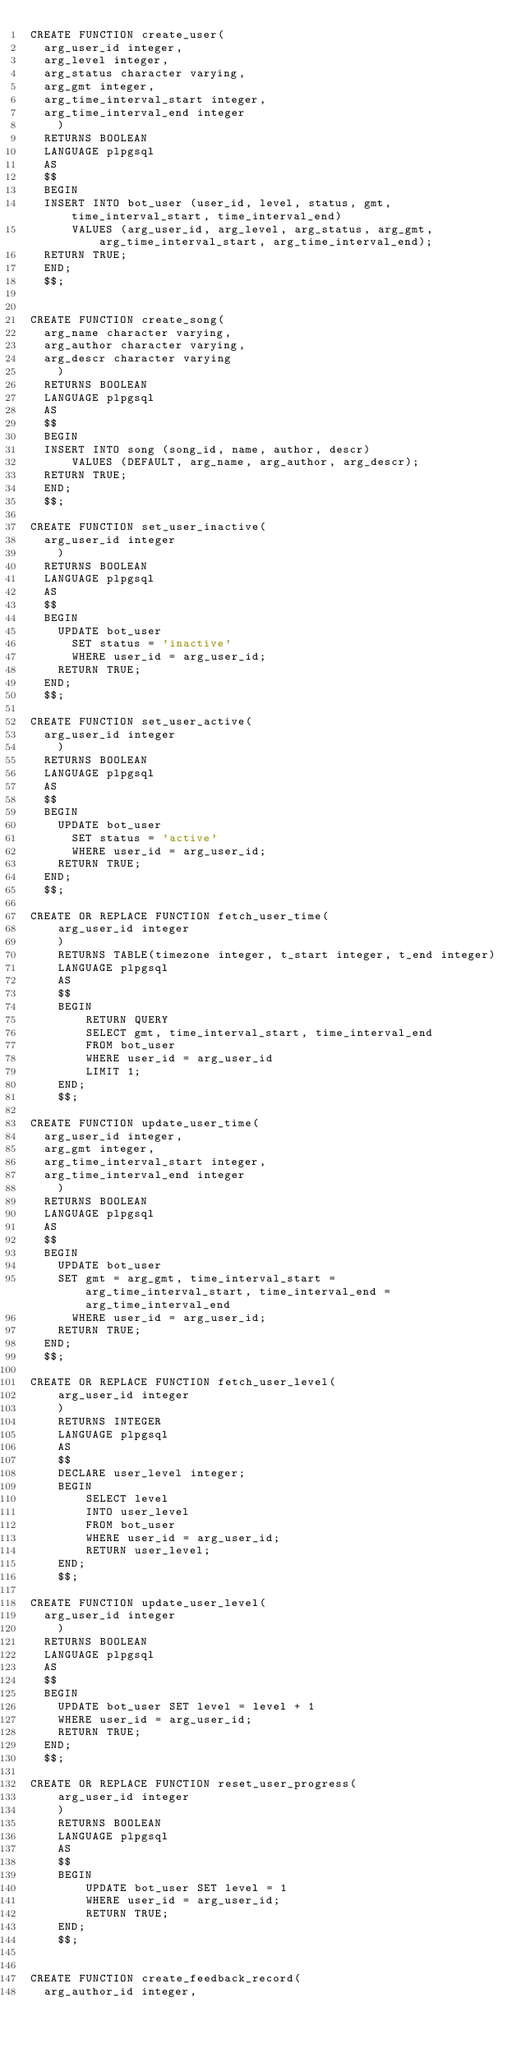<code> <loc_0><loc_0><loc_500><loc_500><_SQL_>CREATE FUNCTION create_user(
	arg_user_id integer,
	arg_level integer,
	arg_status character varying,
	arg_gmt integer,
	arg_time_interval_start integer,
	arg_time_interval_end integer
    )
	RETURNS BOOLEAN
	LANGUAGE plpgsql
	AS
	$$
	BEGIN
	INSERT INTO bot_user (user_id, level, status, gmt, time_interval_start, time_interval_end)
    	VALUES (arg_user_id, arg_level, arg_status, arg_gmt, arg_time_interval_start, arg_time_interval_end);
	RETURN TRUE;
	END;
	$$;


CREATE FUNCTION create_song(
	arg_name character varying,
	arg_author character varying,
	arg_descr character varying
    )
	RETURNS BOOLEAN
	LANGUAGE plpgsql
	AS
	$$
	BEGIN
	INSERT INTO song (song_id, name, author, descr)
    	VALUES (DEFAULT, arg_name, arg_author, arg_descr);
	RETURN TRUE;
	END;
	$$;
	
CREATE FUNCTION set_user_inactive(
	arg_user_id integer
    )
	RETURNS BOOLEAN
	LANGUAGE plpgsql
	AS
	$$
	BEGIN
		UPDATE bot_user
    	SET status = 'inactive'
    	WHERE user_id = arg_user_id;
		RETURN TRUE;
	END;
	$$;

CREATE FUNCTION set_user_active(
	arg_user_id integer
    )
	RETURNS BOOLEAN
	LANGUAGE plpgsql
	AS
	$$
	BEGIN
		UPDATE bot_user
    	SET status = 'active'
    	WHERE user_id = arg_user_id;
		RETURN TRUE;
	END;
	$$;

CREATE OR REPLACE FUNCTION fetch_user_time(
    arg_user_id integer
    )
    RETURNS TABLE(timezone integer, t_start integer, t_end integer)
    LANGUAGE plpgsql
    AS
    $$
    BEGIN
        RETURN QUERY
        SELECT gmt, time_interval_start, time_interval_end
        FROM bot_user
        WHERE user_id = arg_user_id
        LIMIT 1;
    END;
    $$;

CREATE FUNCTION update_user_time(
	arg_user_id integer,
	arg_gmt integer,
	arg_time_interval_start integer,
	arg_time_interval_end integer
    )
	RETURNS BOOLEAN
	LANGUAGE plpgsql
	AS
	$$
	BEGIN
		UPDATE bot_user
		SET gmt = arg_gmt, time_interval_start = arg_time_interval_start, time_interval_end = arg_time_interval_end
    	WHERE user_id = arg_user_id;
		RETURN TRUE;
	END;
	$$;

CREATE OR REPLACE FUNCTION fetch_user_level(
    arg_user_id integer
    )
    RETURNS INTEGER
    LANGUAGE plpgsql
    AS
    $$
    DECLARE user_level integer;
    BEGIN
        SELECT level
        INTO user_level
        FROM bot_user
        WHERE user_id = arg_user_id;
        RETURN user_level;
    END;
    $$;

CREATE FUNCTION update_user_level(
	arg_user_id integer
    )
	RETURNS BOOLEAN
	LANGUAGE plpgsql
	AS
	$$
	BEGIN
		UPDATE bot_user SET level = level + 1 
		WHERE user_id = arg_user_id;
		RETURN TRUE;
	END;
	$$;

CREATE OR REPLACE FUNCTION reset_user_progress(
    arg_user_id integer
    )
    RETURNS BOOLEAN
    LANGUAGE plpgsql
    AS
    $$
    BEGIN
        UPDATE bot_user SET level = 1
        WHERE user_id = arg_user_id;
        RETURN TRUE;
    END;
    $$;


CREATE FUNCTION create_feedback_record(
	arg_author_id integer,</code> 